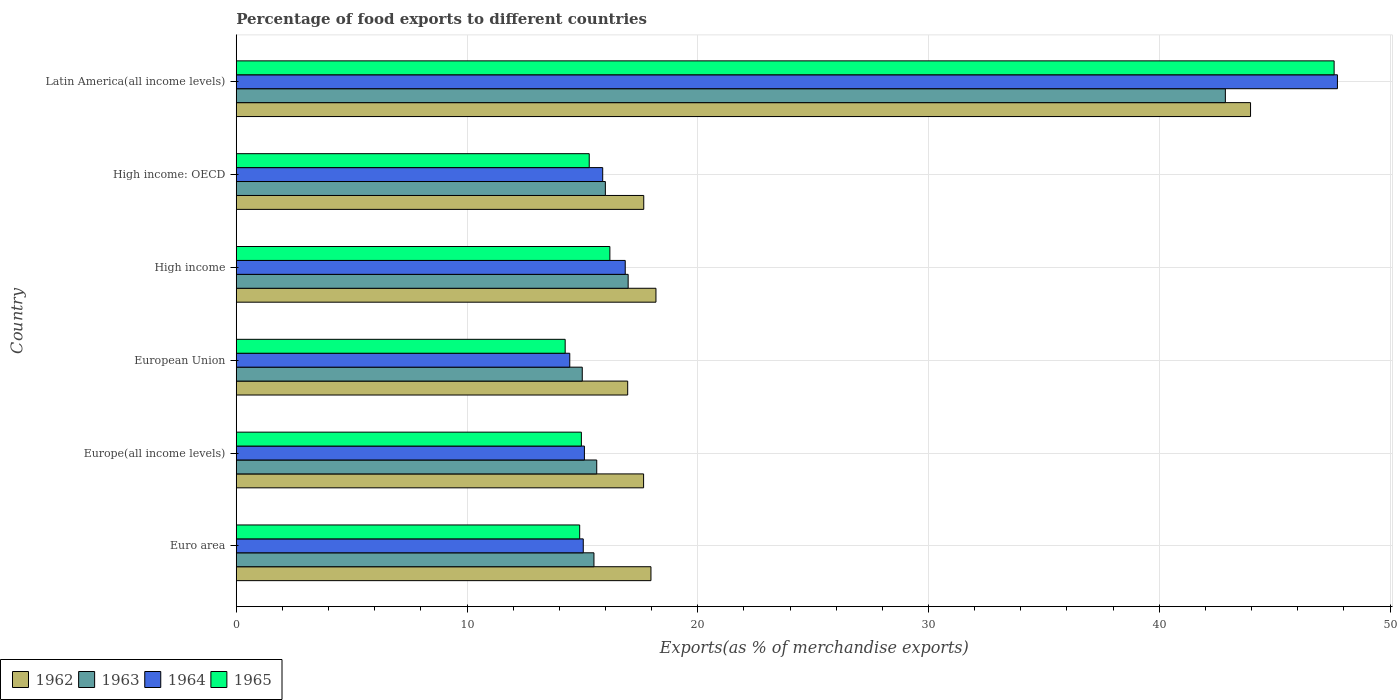How many different coloured bars are there?
Your response must be concise. 4. How many groups of bars are there?
Offer a terse response. 6. Are the number of bars on each tick of the Y-axis equal?
Offer a very short reply. Yes. What is the label of the 5th group of bars from the top?
Make the answer very short. Europe(all income levels). In how many cases, is the number of bars for a given country not equal to the number of legend labels?
Keep it short and to the point. 0. What is the percentage of exports to different countries in 1965 in Euro area?
Offer a very short reply. 14.88. Across all countries, what is the maximum percentage of exports to different countries in 1964?
Your answer should be compact. 47.72. Across all countries, what is the minimum percentage of exports to different countries in 1965?
Ensure brevity in your answer.  14.25. In which country was the percentage of exports to different countries in 1964 maximum?
Give a very brief answer. Latin America(all income levels). In which country was the percentage of exports to different countries in 1963 minimum?
Offer a very short reply. European Union. What is the total percentage of exports to different countries in 1962 in the graph?
Make the answer very short. 132.39. What is the difference between the percentage of exports to different countries in 1962 in Europe(all income levels) and that in High income: OECD?
Keep it short and to the point. -0.01. What is the difference between the percentage of exports to different countries in 1962 in High income and the percentage of exports to different countries in 1965 in European Union?
Offer a very short reply. 3.93. What is the average percentage of exports to different countries in 1963 per country?
Keep it short and to the point. 20.33. What is the difference between the percentage of exports to different countries in 1965 and percentage of exports to different countries in 1962 in Latin America(all income levels)?
Your answer should be compact. 3.62. What is the ratio of the percentage of exports to different countries in 1963 in European Union to that in High income: OECD?
Ensure brevity in your answer.  0.94. Is the percentage of exports to different countries in 1963 in High income less than that in Latin America(all income levels)?
Your answer should be very brief. Yes. Is the difference between the percentage of exports to different countries in 1965 in European Union and Latin America(all income levels) greater than the difference between the percentage of exports to different countries in 1962 in European Union and Latin America(all income levels)?
Keep it short and to the point. No. What is the difference between the highest and the second highest percentage of exports to different countries in 1962?
Offer a very short reply. 25.77. What is the difference between the highest and the lowest percentage of exports to different countries in 1962?
Your answer should be compact. 26.99. In how many countries, is the percentage of exports to different countries in 1962 greater than the average percentage of exports to different countries in 1962 taken over all countries?
Your answer should be compact. 1. Is the sum of the percentage of exports to different countries in 1964 in Euro area and High income: OECD greater than the maximum percentage of exports to different countries in 1963 across all countries?
Keep it short and to the point. No. Is it the case that in every country, the sum of the percentage of exports to different countries in 1964 and percentage of exports to different countries in 1962 is greater than the sum of percentage of exports to different countries in 1965 and percentage of exports to different countries in 1963?
Offer a terse response. No. What does the 4th bar from the bottom in High income represents?
Offer a very short reply. 1965. Is it the case that in every country, the sum of the percentage of exports to different countries in 1963 and percentage of exports to different countries in 1964 is greater than the percentage of exports to different countries in 1962?
Offer a terse response. Yes. How many bars are there?
Ensure brevity in your answer.  24. How many countries are there in the graph?
Your answer should be compact. 6. Does the graph contain any zero values?
Offer a terse response. No. Does the graph contain grids?
Offer a very short reply. Yes. Where does the legend appear in the graph?
Your answer should be very brief. Bottom left. How are the legend labels stacked?
Your response must be concise. Horizontal. What is the title of the graph?
Provide a short and direct response. Percentage of food exports to different countries. Does "1985" appear as one of the legend labels in the graph?
Provide a succinct answer. No. What is the label or title of the X-axis?
Your answer should be very brief. Exports(as % of merchandise exports). What is the label or title of the Y-axis?
Offer a terse response. Country. What is the Exports(as % of merchandise exports) of 1962 in Euro area?
Ensure brevity in your answer.  17.97. What is the Exports(as % of merchandise exports) of 1963 in Euro area?
Your response must be concise. 15.5. What is the Exports(as % of merchandise exports) in 1964 in Euro area?
Provide a succinct answer. 15.04. What is the Exports(as % of merchandise exports) in 1965 in Euro area?
Ensure brevity in your answer.  14.88. What is the Exports(as % of merchandise exports) of 1962 in Europe(all income levels)?
Your response must be concise. 17.65. What is the Exports(as % of merchandise exports) of 1963 in Europe(all income levels)?
Provide a short and direct response. 15.62. What is the Exports(as % of merchandise exports) in 1964 in Europe(all income levels)?
Your answer should be compact. 15.09. What is the Exports(as % of merchandise exports) in 1965 in Europe(all income levels)?
Offer a terse response. 14.96. What is the Exports(as % of merchandise exports) of 1962 in European Union?
Offer a very short reply. 16.96. What is the Exports(as % of merchandise exports) in 1963 in European Union?
Your answer should be very brief. 14.99. What is the Exports(as % of merchandise exports) in 1964 in European Union?
Keep it short and to the point. 14.45. What is the Exports(as % of merchandise exports) of 1965 in European Union?
Your answer should be compact. 14.25. What is the Exports(as % of merchandise exports) of 1962 in High income?
Provide a short and direct response. 18.19. What is the Exports(as % of merchandise exports) in 1963 in High income?
Your response must be concise. 16.98. What is the Exports(as % of merchandise exports) of 1964 in High income?
Provide a short and direct response. 16.86. What is the Exports(as % of merchandise exports) of 1965 in High income?
Your answer should be very brief. 16.19. What is the Exports(as % of merchandise exports) of 1962 in High income: OECD?
Your answer should be compact. 17.66. What is the Exports(as % of merchandise exports) in 1963 in High income: OECD?
Your response must be concise. 16. What is the Exports(as % of merchandise exports) in 1964 in High income: OECD?
Offer a very short reply. 15.88. What is the Exports(as % of merchandise exports) in 1965 in High income: OECD?
Your answer should be very brief. 15.3. What is the Exports(as % of merchandise exports) of 1962 in Latin America(all income levels)?
Provide a short and direct response. 43.96. What is the Exports(as % of merchandise exports) in 1963 in Latin America(all income levels)?
Your answer should be compact. 42.86. What is the Exports(as % of merchandise exports) of 1964 in Latin America(all income levels)?
Provide a succinct answer. 47.72. What is the Exports(as % of merchandise exports) in 1965 in Latin America(all income levels)?
Provide a succinct answer. 47.58. Across all countries, what is the maximum Exports(as % of merchandise exports) of 1962?
Provide a succinct answer. 43.96. Across all countries, what is the maximum Exports(as % of merchandise exports) in 1963?
Make the answer very short. 42.86. Across all countries, what is the maximum Exports(as % of merchandise exports) of 1964?
Your response must be concise. 47.72. Across all countries, what is the maximum Exports(as % of merchandise exports) of 1965?
Keep it short and to the point. 47.58. Across all countries, what is the minimum Exports(as % of merchandise exports) of 1962?
Provide a succinct answer. 16.96. Across all countries, what is the minimum Exports(as % of merchandise exports) of 1963?
Make the answer very short. 14.99. Across all countries, what is the minimum Exports(as % of merchandise exports) in 1964?
Offer a very short reply. 14.45. Across all countries, what is the minimum Exports(as % of merchandise exports) of 1965?
Offer a terse response. 14.25. What is the total Exports(as % of merchandise exports) in 1962 in the graph?
Your response must be concise. 132.39. What is the total Exports(as % of merchandise exports) in 1963 in the graph?
Ensure brevity in your answer.  121.96. What is the total Exports(as % of merchandise exports) in 1964 in the graph?
Your answer should be very brief. 125.04. What is the total Exports(as % of merchandise exports) of 1965 in the graph?
Offer a terse response. 123.16. What is the difference between the Exports(as % of merchandise exports) in 1962 in Euro area and that in Europe(all income levels)?
Offer a terse response. 0.32. What is the difference between the Exports(as % of merchandise exports) in 1963 in Euro area and that in Europe(all income levels)?
Ensure brevity in your answer.  -0.12. What is the difference between the Exports(as % of merchandise exports) of 1964 in Euro area and that in Europe(all income levels)?
Provide a succinct answer. -0.05. What is the difference between the Exports(as % of merchandise exports) of 1965 in Euro area and that in Europe(all income levels)?
Provide a short and direct response. -0.07. What is the difference between the Exports(as % of merchandise exports) of 1962 in Euro area and that in European Union?
Offer a terse response. 1.01. What is the difference between the Exports(as % of merchandise exports) in 1963 in Euro area and that in European Union?
Your answer should be very brief. 0.51. What is the difference between the Exports(as % of merchandise exports) in 1964 in Euro area and that in European Union?
Keep it short and to the point. 0.58. What is the difference between the Exports(as % of merchandise exports) of 1965 in Euro area and that in European Union?
Give a very brief answer. 0.63. What is the difference between the Exports(as % of merchandise exports) in 1962 in Euro area and that in High income?
Make the answer very short. -0.22. What is the difference between the Exports(as % of merchandise exports) of 1963 in Euro area and that in High income?
Keep it short and to the point. -1.48. What is the difference between the Exports(as % of merchandise exports) in 1964 in Euro area and that in High income?
Your response must be concise. -1.82. What is the difference between the Exports(as % of merchandise exports) in 1965 in Euro area and that in High income?
Offer a very short reply. -1.31. What is the difference between the Exports(as % of merchandise exports) of 1962 in Euro area and that in High income: OECD?
Offer a very short reply. 0.31. What is the difference between the Exports(as % of merchandise exports) in 1963 in Euro area and that in High income: OECD?
Provide a succinct answer. -0.49. What is the difference between the Exports(as % of merchandise exports) of 1964 in Euro area and that in High income: OECD?
Make the answer very short. -0.84. What is the difference between the Exports(as % of merchandise exports) in 1965 in Euro area and that in High income: OECD?
Your response must be concise. -0.41. What is the difference between the Exports(as % of merchandise exports) in 1962 in Euro area and that in Latin America(all income levels)?
Ensure brevity in your answer.  -25.98. What is the difference between the Exports(as % of merchandise exports) in 1963 in Euro area and that in Latin America(all income levels)?
Provide a succinct answer. -27.36. What is the difference between the Exports(as % of merchandise exports) in 1964 in Euro area and that in Latin America(all income levels)?
Ensure brevity in your answer.  -32.68. What is the difference between the Exports(as % of merchandise exports) of 1965 in Euro area and that in Latin America(all income levels)?
Offer a terse response. -32.69. What is the difference between the Exports(as % of merchandise exports) of 1962 in Europe(all income levels) and that in European Union?
Provide a short and direct response. 0.69. What is the difference between the Exports(as % of merchandise exports) of 1963 in Europe(all income levels) and that in European Union?
Provide a succinct answer. 0.63. What is the difference between the Exports(as % of merchandise exports) in 1964 in Europe(all income levels) and that in European Union?
Your answer should be very brief. 0.63. What is the difference between the Exports(as % of merchandise exports) of 1965 in Europe(all income levels) and that in European Union?
Give a very brief answer. 0.7. What is the difference between the Exports(as % of merchandise exports) in 1962 in Europe(all income levels) and that in High income?
Keep it short and to the point. -0.54. What is the difference between the Exports(as % of merchandise exports) in 1963 in Europe(all income levels) and that in High income?
Your answer should be very brief. -1.36. What is the difference between the Exports(as % of merchandise exports) in 1964 in Europe(all income levels) and that in High income?
Your response must be concise. -1.77. What is the difference between the Exports(as % of merchandise exports) of 1965 in Europe(all income levels) and that in High income?
Your answer should be compact. -1.23. What is the difference between the Exports(as % of merchandise exports) of 1962 in Europe(all income levels) and that in High income: OECD?
Give a very brief answer. -0.01. What is the difference between the Exports(as % of merchandise exports) of 1963 in Europe(all income levels) and that in High income: OECD?
Your response must be concise. -0.37. What is the difference between the Exports(as % of merchandise exports) in 1964 in Europe(all income levels) and that in High income: OECD?
Your response must be concise. -0.79. What is the difference between the Exports(as % of merchandise exports) in 1965 in Europe(all income levels) and that in High income: OECD?
Provide a short and direct response. -0.34. What is the difference between the Exports(as % of merchandise exports) in 1962 in Europe(all income levels) and that in Latin America(all income levels)?
Your answer should be very brief. -26.3. What is the difference between the Exports(as % of merchandise exports) in 1963 in Europe(all income levels) and that in Latin America(all income levels)?
Keep it short and to the point. -27.24. What is the difference between the Exports(as % of merchandise exports) in 1964 in Europe(all income levels) and that in Latin America(all income levels)?
Offer a very short reply. -32.63. What is the difference between the Exports(as % of merchandise exports) in 1965 in Europe(all income levels) and that in Latin America(all income levels)?
Offer a terse response. -32.62. What is the difference between the Exports(as % of merchandise exports) in 1962 in European Union and that in High income?
Provide a succinct answer. -1.22. What is the difference between the Exports(as % of merchandise exports) in 1963 in European Union and that in High income?
Offer a terse response. -1.99. What is the difference between the Exports(as % of merchandise exports) in 1964 in European Union and that in High income?
Keep it short and to the point. -2.4. What is the difference between the Exports(as % of merchandise exports) of 1965 in European Union and that in High income?
Give a very brief answer. -1.94. What is the difference between the Exports(as % of merchandise exports) in 1962 in European Union and that in High income: OECD?
Your answer should be very brief. -0.7. What is the difference between the Exports(as % of merchandise exports) of 1963 in European Union and that in High income: OECD?
Ensure brevity in your answer.  -1. What is the difference between the Exports(as % of merchandise exports) of 1964 in European Union and that in High income: OECD?
Ensure brevity in your answer.  -1.43. What is the difference between the Exports(as % of merchandise exports) of 1965 in European Union and that in High income: OECD?
Your answer should be very brief. -1.04. What is the difference between the Exports(as % of merchandise exports) of 1962 in European Union and that in Latin America(all income levels)?
Your answer should be very brief. -26.99. What is the difference between the Exports(as % of merchandise exports) in 1963 in European Union and that in Latin America(all income levels)?
Your answer should be compact. -27.87. What is the difference between the Exports(as % of merchandise exports) in 1964 in European Union and that in Latin America(all income levels)?
Ensure brevity in your answer.  -33.27. What is the difference between the Exports(as % of merchandise exports) of 1965 in European Union and that in Latin America(all income levels)?
Offer a terse response. -33.32. What is the difference between the Exports(as % of merchandise exports) in 1962 in High income and that in High income: OECD?
Make the answer very short. 0.53. What is the difference between the Exports(as % of merchandise exports) in 1963 in High income and that in High income: OECD?
Provide a short and direct response. 0.99. What is the difference between the Exports(as % of merchandise exports) in 1964 in High income and that in High income: OECD?
Make the answer very short. 0.98. What is the difference between the Exports(as % of merchandise exports) in 1965 in High income and that in High income: OECD?
Ensure brevity in your answer.  0.89. What is the difference between the Exports(as % of merchandise exports) in 1962 in High income and that in Latin America(all income levels)?
Provide a succinct answer. -25.77. What is the difference between the Exports(as % of merchandise exports) of 1963 in High income and that in Latin America(all income levels)?
Keep it short and to the point. -25.88. What is the difference between the Exports(as % of merchandise exports) of 1964 in High income and that in Latin America(all income levels)?
Provide a succinct answer. -30.86. What is the difference between the Exports(as % of merchandise exports) of 1965 in High income and that in Latin America(all income levels)?
Your response must be concise. -31.39. What is the difference between the Exports(as % of merchandise exports) of 1962 in High income: OECD and that in Latin America(all income levels)?
Make the answer very short. -26.3. What is the difference between the Exports(as % of merchandise exports) in 1963 in High income: OECD and that in Latin America(all income levels)?
Ensure brevity in your answer.  -26.87. What is the difference between the Exports(as % of merchandise exports) in 1964 in High income: OECD and that in Latin America(all income levels)?
Make the answer very short. -31.84. What is the difference between the Exports(as % of merchandise exports) of 1965 in High income: OECD and that in Latin America(all income levels)?
Ensure brevity in your answer.  -32.28. What is the difference between the Exports(as % of merchandise exports) of 1962 in Euro area and the Exports(as % of merchandise exports) of 1963 in Europe(all income levels)?
Offer a terse response. 2.35. What is the difference between the Exports(as % of merchandise exports) of 1962 in Euro area and the Exports(as % of merchandise exports) of 1964 in Europe(all income levels)?
Your answer should be very brief. 2.88. What is the difference between the Exports(as % of merchandise exports) of 1962 in Euro area and the Exports(as % of merchandise exports) of 1965 in Europe(all income levels)?
Give a very brief answer. 3.02. What is the difference between the Exports(as % of merchandise exports) of 1963 in Euro area and the Exports(as % of merchandise exports) of 1964 in Europe(all income levels)?
Ensure brevity in your answer.  0.41. What is the difference between the Exports(as % of merchandise exports) in 1963 in Euro area and the Exports(as % of merchandise exports) in 1965 in Europe(all income levels)?
Your answer should be compact. 0.55. What is the difference between the Exports(as % of merchandise exports) of 1964 in Euro area and the Exports(as % of merchandise exports) of 1965 in Europe(all income levels)?
Your answer should be very brief. 0.08. What is the difference between the Exports(as % of merchandise exports) in 1962 in Euro area and the Exports(as % of merchandise exports) in 1963 in European Union?
Give a very brief answer. 2.98. What is the difference between the Exports(as % of merchandise exports) in 1962 in Euro area and the Exports(as % of merchandise exports) in 1964 in European Union?
Make the answer very short. 3.52. What is the difference between the Exports(as % of merchandise exports) of 1962 in Euro area and the Exports(as % of merchandise exports) of 1965 in European Union?
Give a very brief answer. 3.72. What is the difference between the Exports(as % of merchandise exports) of 1963 in Euro area and the Exports(as % of merchandise exports) of 1964 in European Union?
Give a very brief answer. 1.05. What is the difference between the Exports(as % of merchandise exports) in 1963 in Euro area and the Exports(as % of merchandise exports) in 1965 in European Union?
Offer a very short reply. 1.25. What is the difference between the Exports(as % of merchandise exports) of 1964 in Euro area and the Exports(as % of merchandise exports) of 1965 in European Union?
Keep it short and to the point. 0.78. What is the difference between the Exports(as % of merchandise exports) in 1962 in Euro area and the Exports(as % of merchandise exports) in 1963 in High income?
Offer a very short reply. 0.99. What is the difference between the Exports(as % of merchandise exports) in 1962 in Euro area and the Exports(as % of merchandise exports) in 1964 in High income?
Make the answer very short. 1.11. What is the difference between the Exports(as % of merchandise exports) in 1962 in Euro area and the Exports(as % of merchandise exports) in 1965 in High income?
Your answer should be very brief. 1.78. What is the difference between the Exports(as % of merchandise exports) of 1963 in Euro area and the Exports(as % of merchandise exports) of 1964 in High income?
Keep it short and to the point. -1.36. What is the difference between the Exports(as % of merchandise exports) in 1963 in Euro area and the Exports(as % of merchandise exports) in 1965 in High income?
Give a very brief answer. -0.69. What is the difference between the Exports(as % of merchandise exports) in 1964 in Euro area and the Exports(as % of merchandise exports) in 1965 in High income?
Make the answer very short. -1.15. What is the difference between the Exports(as % of merchandise exports) of 1962 in Euro area and the Exports(as % of merchandise exports) of 1963 in High income: OECD?
Provide a short and direct response. 1.98. What is the difference between the Exports(as % of merchandise exports) in 1962 in Euro area and the Exports(as % of merchandise exports) in 1964 in High income: OECD?
Your answer should be very brief. 2.09. What is the difference between the Exports(as % of merchandise exports) of 1962 in Euro area and the Exports(as % of merchandise exports) of 1965 in High income: OECD?
Give a very brief answer. 2.67. What is the difference between the Exports(as % of merchandise exports) of 1963 in Euro area and the Exports(as % of merchandise exports) of 1964 in High income: OECD?
Give a very brief answer. -0.38. What is the difference between the Exports(as % of merchandise exports) in 1963 in Euro area and the Exports(as % of merchandise exports) in 1965 in High income: OECD?
Give a very brief answer. 0.2. What is the difference between the Exports(as % of merchandise exports) in 1964 in Euro area and the Exports(as % of merchandise exports) in 1965 in High income: OECD?
Provide a succinct answer. -0.26. What is the difference between the Exports(as % of merchandise exports) in 1962 in Euro area and the Exports(as % of merchandise exports) in 1963 in Latin America(all income levels)?
Your answer should be compact. -24.89. What is the difference between the Exports(as % of merchandise exports) in 1962 in Euro area and the Exports(as % of merchandise exports) in 1964 in Latin America(all income levels)?
Make the answer very short. -29.75. What is the difference between the Exports(as % of merchandise exports) of 1962 in Euro area and the Exports(as % of merchandise exports) of 1965 in Latin America(all income levels)?
Offer a terse response. -29.61. What is the difference between the Exports(as % of merchandise exports) of 1963 in Euro area and the Exports(as % of merchandise exports) of 1964 in Latin America(all income levels)?
Offer a terse response. -32.22. What is the difference between the Exports(as % of merchandise exports) of 1963 in Euro area and the Exports(as % of merchandise exports) of 1965 in Latin America(all income levels)?
Your response must be concise. -32.08. What is the difference between the Exports(as % of merchandise exports) of 1964 in Euro area and the Exports(as % of merchandise exports) of 1965 in Latin America(all income levels)?
Ensure brevity in your answer.  -32.54. What is the difference between the Exports(as % of merchandise exports) of 1962 in Europe(all income levels) and the Exports(as % of merchandise exports) of 1963 in European Union?
Your answer should be compact. 2.66. What is the difference between the Exports(as % of merchandise exports) in 1962 in Europe(all income levels) and the Exports(as % of merchandise exports) in 1964 in European Union?
Your response must be concise. 3.2. What is the difference between the Exports(as % of merchandise exports) of 1962 in Europe(all income levels) and the Exports(as % of merchandise exports) of 1965 in European Union?
Offer a terse response. 3.4. What is the difference between the Exports(as % of merchandise exports) of 1963 in Europe(all income levels) and the Exports(as % of merchandise exports) of 1964 in European Union?
Make the answer very short. 1.17. What is the difference between the Exports(as % of merchandise exports) of 1963 in Europe(all income levels) and the Exports(as % of merchandise exports) of 1965 in European Union?
Provide a short and direct response. 1.37. What is the difference between the Exports(as % of merchandise exports) in 1964 in Europe(all income levels) and the Exports(as % of merchandise exports) in 1965 in European Union?
Keep it short and to the point. 0.83. What is the difference between the Exports(as % of merchandise exports) of 1962 in Europe(all income levels) and the Exports(as % of merchandise exports) of 1963 in High income?
Your response must be concise. 0.67. What is the difference between the Exports(as % of merchandise exports) of 1962 in Europe(all income levels) and the Exports(as % of merchandise exports) of 1964 in High income?
Make the answer very short. 0.8. What is the difference between the Exports(as % of merchandise exports) of 1962 in Europe(all income levels) and the Exports(as % of merchandise exports) of 1965 in High income?
Ensure brevity in your answer.  1.46. What is the difference between the Exports(as % of merchandise exports) in 1963 in Europe(all income levels) and the Exports(as % of merchandise exports) in 1964 in High income?
Offer a terse response. -1.24. What is the difference between the Exports(as % of merchandise exports) of 1963 in Europe(all income levels) and the Exports(as % of merchandise exports) of 1965 in High income?
Provide a short and direct response. -0.57. What is the difference between the Exports(as % of merchandise exports) in 1964 in Europe(all income levels) and the Exports(as % of merchandise exports) in 1965 in High income?
Offer a terse response. -1.1. What is the difference between the Exports(as % of merchandise exports) in 1962 in Europe(all income levels) and the Exports(as % of merchandise exports) in 1963 in High income: OECD?
Your response must be concise. 1.66. What is the difference between the Exports(as % of merchandise exports) of 1962 in Europe(all income levels) and the Exports(as % of merchandise exports) of 1964 in High income: OECD?
Offer a terse response. 1.77. What is the difference between the Exports(as % of merchandise exports) in 1962 in Europe(all income levels) and the Exports(as % of merchandise exports) in 1965 in High income: OECD?
Offer a terse response. 2.36. What is the difference between the Exports(as % of merchandise exports) in 1963 in Europe(all income levels) and the Exports(as % of merchandise exports) in 1964 in High income: OECD?
Offer a very short reply. -0.26. What is the difference between the Exports(as % of merchandise exports) of 1963 in Europe(all income levels) and the Exports(as % of merchandise exports) of 1965 in High income: OECD?
Your answer should be compact. 0.33. What is the difference between the Exports(as % of merchandise exports) of 1964 in Europe(all income levels) and the Exports(as % of merchandise exports) of 1965 in High income: OECD?
Offer a terse response. -0.21. What is the difference between the Exports(as % of merchandise exports) of 1962 in Europe(all income levels) and the Exports(as % of merchandise exports) of 1963 in Latin America(all income levels)?
Ensure brevity in your answer.  -25.21. What is the difference between the Exports(as % of merchandise exports) of 1962 in Europe(all income levels) and the Exports(as % of merchandise exports) of 1964 in Latin America(all income levels)?
Offer a very short reply. -30.07. What is the difference between the Exports(as % of merchandise exports) of 1962 in Europe(all income levels) and the Exports(as % of merchandise exports) of 1965 in Latin America(all income levels)?
Provide a succinct answer. -29.92. What is the difference between the Exports(as % of merchandise exports) of 1963 in Europe(all income levels) and the Exports(as % of merchandise exports) of 1964 in Latin America(all income levels)?
Provide a short and direct response. -32.1. What is the difference between the Exports(as % of merchandise exports) of 1963 in Europe(all income levels) and the Exports(as % of merchandise exports) of 1965 in Latin America(all income levels)?
Your answer should be very brief. -31.96. What is the difference between the Exports(as % of merchandise exports) of 1964 in Europe(all income levels) and the Exports(as % of merchandise exports) of 1965 in Latin America(all income levels)?
Your answer should be very brief. -32.49. What is the difference between the Exports(as % of merchandise exports) in 1962 in European Union and the Exports(as % of merchandise exports) in 1963 in High income?
Offer a very short reply. -0.02. What is the difference between the Exports(as % of merchandise exports) of 1962 in European Union and the Exports(as % of merchandise exports) of 1964 in High income?
Ensure brevity in your answer.  0.11. What is the difference between the Exports(as % of merchandise exports) in 1962 in European Union and the Exports(as % of merchandise exports) in 1965 in High income?
Ensure brevity in your answer.  0.77. What is the difference between the Exports(as % of merchandise exports) in 1963 in European Union and the Exports(as % of merchandise exports) in 1964 in High income?
Provide a succinct answer. -1.86. What is the difference between the Exports(as % of merchandise exports) of 1963 in European Union and the Exports(as % of merchandise exports) of 1965 in High income?
Give a very brief answer. -1.2. What is the difference between the Exports(as % of merchandise exports) of 1964 in European Union and the Exports(as % of merchandise exports) of 1965 in High income?
Offer a very short reply. -1.74. What is the difference between the Exports(as % of merchandise exports) of 1962 in European Union and the Exports(as % of merchandise exports) of 1963 in High income: OECD?
Your response must be concise. 0.97. What is the difference between the Exports(as % of merchandise exports) of 1962 in European Union and the Exports(as % of merchandise exports) of 1964 in High income: OECD?
Your answer should be compact. 1.08. What is the difference between the Exports(as % of merchandise exports) of 1962 in European Union and the Exports(as % of merchandise exports) of 1965 in High income: OECD?
Offer a very short reply. 1.67. What is the difference between the Exports(as % of merchandise exports) of 1963 in European Union and the Exports(as % of merchandise exports) of 1964 in High income: OECD?
Provide a short and direct response. -0.89. What is the difference between the Exports(as % of merchandise exports) in 1963 in European Union and the Exports(as % of merchandise exports) in 1965 in High income: OECD?
Your answer should be very brief. -0.3. What is the difference between the Exports(as % of merchandise exports) in 1964 in European Union and the Exports(as % of merchandise exports) in 1965 in High income: OECD?
Give a very brief answer. -0.84. What is the difference between the Exports(as % of merchandise exports) in 1962 in European Union and the Exports(as % of merchandise exports) in 1963 in Latin America(all income levels)?
Keep it short and to the point. -25.9. What is the difference between the Exports(as % of merchandise exports) of 1962 in European Union and the Exports(as % of merchandise exports) of 1964 in Latin America(all income levels)?
Your response must be concise. -30.76. What is the difference between the Exports(as % of merchandise exports) of 1962 in European Union and the Exports(as % of merchandise exports) of 1965 in Latin America(all income levels)?
Keep it short and to the point. -30.61. What is the difference between the Exports(as % of merchandise exports) of 1963 in European Union and the Exports(as % of merchandise exports) of 1964 in Latin America(all income levels)?
Ensure brevity in your answer.  -32.73. What is the difference between the Exports(as % of merchandise exports) in 1963 in European Union and the Exports(as % of merchandise exports) in 1965 in Latin America(all income levels)?
Provide a short and direct response. -32.58. What is the difference between the Exports(as % of merchandise exports) in 1964 in European Union and the Exports(as % of merchandise exports) in 1965 in Latin America(all income levels)?
Provide a succinct answer. -33.12. What is the difference between the Exports(as % of merchandise exports) of 1962 in High income and the Exports(as % of merchandise exports) of 1963 in High income: OECD?
Make the answer very short. 2.19. What is the difference between the Exports(as % of merchandise exports) of 1962 in High income and the Exports(as % of merchandise exports) of 1964 in High income: OECD?
Your response must be concise. 2.31. What is the difference between the Exports(as % of merchandise exports) of 1962 in High income and the Exports(as % of merchandise exports) of 1965 in High income: OECD?
Keep it short and to the point. 2.89. What is the difference between the Exports(as % of merchandise exports) of 1963 in High income and the Exports(as % of merchandise exports) of 1964 in High income: OECD?
Give a very brief answer. 1.1. What is the difference between the Exports(as % of merchandise exports) of 1963 in High income and the Exports(as % of merchandise exports) of 1965 in High income: OECD?
Your answer should be very brief. 1.69. What is the difference between the Exports(as % of merchandise exports) in 1964 in High income and the Exports(as % of merchandise exports) in 1965 in High income: OECD?
Give a very brief answer. 1.56. What is the difference between the Exports(as % of merchandise exports) of 1962 in High income and the Exports(as % of merchandise exports) of 1963 in Latin America(all income levels)?
Offer a terse response. -24.68. What is the difference between the Exports(as % of merchandise exports) of 1962 in High income and the Exports(as % of merchandise exports) of 1964 in Latin America(all income levels)?
Offer a terse response. -29.53. What is the difference between the Exports(as % of merchandise exports) in 1962 in High income and the Exports(as % of merchandise exports) in 1965 in Latin America(all income levels)?
Make the answer very short. -29.39. What is the difference between the Exports(as % of merchandise exports) of 1963 in High income and the Exports(as % of merchandise exports) of 1964 in Latin America(all income levels)?
Ensure brevity in your answer.  -30.74. What is the difference between the Exports(as % of merchandise exports) in 1963 in High income and the Exports(as % of merchandise exports) in 1965 in Latin America(all income levels)?
Ensure brevity in your answer.  -30.59. What is the difference between the Exports(as % of merchandise exports) in 1964 in High income and the Exports(as % of merchandise exports) in 1965 in Latin America(all income levels)?
Keep it short and to the point. -30.72. What is the difference between the Exports(as % of merchandise exports) of 1962 in High income: OECD and the Exports(as % of merchandise exports) of 1963 in Latin America(all income levels)?
Give a very brief answer. -25.2. What is the difference between the Exports(as % of merchandise exports) of 1962 in High income: OECD and the Exports(as % of merchandise exports) of 1964 in Latin America(all income levels)?
Ensure brevity in your answer.  -30.06. What is the difference between the Exports(as % of merchandise exports) of 1962 in High income: OECD and the Exports(as % of merchandise exports) of 1965 in Latin America(all income levels)?
Keep it short and to the point. -29.92. What is the difference between the Exports(as % of merchandise exports) of 1963 in High income: OECD and the Exports(as % of merchandise exports) of 1964 in Latin America(all income levels)?
Keep it short and to the point. -31.73. What is the difference between the Exports(as % of merchandise exports) in 1963 in High income: OECD and the Exports(as % of merchandise exports) in 1965 in Latin America(all income levels)?
Offer a terse response. -31.58. What is the difference between the Exports(as % of merchandise exports) of 1964 in High income: OECD and the Exports(as % of merchandise exports) of 1965 in Latin America(all income levels)?
Keep it short and to the point. -31.7. What is the average Exports(as % of merchandise exports) in 1962 per country?
Your response must be concise. 22.07. What is the average Exports(as % of merchandise exports) of 1963 per country?
Offer a very short reply. 20.33. What is the average Exports(as % of merchandise exports) in 1964 per country?
Ensure brevity in your answer.  20.84. What is the average Exports(as % of merchandise exports) in 1965 per country?
Keep it short and to the point. 20.53. What is the difference between the Exports(as % of merchandise exports) in 1962 and Exports(as % of merchandise exports) in 1963 in Euro area?
Your answer should be very brief. 2.47. What is the difference between the Exports(as % of merchandise exports) of 1962 and Exports(as % of merchandise exports) of 1964 in Euro area?
Provide a short and direct response. 2.93. What is the difference between the Exports(as % of merchandise exports) in 1962 and Exports(as % of merchandise exports) in 1965 in Euro area?
Provide a short and direct response. 3.09. What is the difference between the Exports(as % of merchandise exports) of 1963 and Exports(as % of merchandise exports) of 1964 in Euro area?
Make the answer very short. 0.46. What is the difference between the Exports(as % of merchandise exports) in 1963 and Exports(as % of merchandise exports) in 1965 in Euro area?
Keep it short and to the point. 0.62. What is the difference between the Exports(as % of merchandise exports) of 1964 and Exports(as % of merchandise exports) of 1965 in Euro area?
Provide a short and direct response. 0.15. What is the difference between the Exports(as % of merchandise exports) in 1962 and Exports(as % of merchandise exports) in 1963 in Europe(all income levels)?
Offer a very short reply. 2.03. What is the difference between the Exports(as % of merchandise exports) of 1962 and Exports(as % of merchandise exports) of 1964 in Europe(all income levels)?
Your response must be concise. 2.57. What is the difference between the Exports(as % of merchandise exports) of 1962 and Exports(as % of merchandise exports) of 1965 in Europe(all income levels)?
Offer a very short reply. 2.7. What is the difference between the Exports(as % of merchandise exports) in 1963 and Exports(as % of merchandise exports) in 1964 in Europe(all income levels)?
Give a very brief answer. 0.53. What is the difference between the Exports(as % of merchandise exports) in 1963 and Exports(as % of merchandise exports) in 1965 in Europe(all income levels)?
Provide a succinct answer. 0.67. What is the difference between the Exports(as % of merchandise exports) of 1964 and Exports(as % of merchandise exports) of 1965 in Europe(all income levels)?
Your answer should be compact. 0.13. What is the difference between the Exports(as % of merchandise exports) in 1962 and Exports(as % of merchandise exports) in 1963 in European Union?
Ensure brevity in your answer.  1.97. What is the difference between the Exports(as % of merchandise exports) of 1962 and Exports(as % of merchandise exports) of 1964 in European Union?
Make the answer very short. 2.51. What is the difference between the Exports(as % of merchandise exports) of 1962 and Exports(as % of merchandise exports) of 1965 in European Union?
Your answer should be very brief. 2.71. What is the difference between the Exports(as % of merchandise exports) in 1963 and Exports(as % of merchandise exports) in 1964 in European Union?
Keep it short and to the point. 0.54. What is the difference between the Exports(as % of merchandise exports) of 1963 and Exports(as % of merchandise exports) of 1965 in European Union?
Make the answer very short. 0.74. What is the difference between the Exports(as % of merchandise exports) in 1964 and Exports(as % of merchandise exports) in 1965 in European Union?
Provide a short and direct response. 0.2. What is the difference between the Exports(as % of merchandise exports) of 1962 and Exports(as % of merchandise exports) of 1963 in High income?
Ensure brevity in your answer.  1.2. What is the difference between the Exports(as % of merchandise exports) of 1962 and Exports(as % of merchandise exports) of 1964 in High income?
Make the answer very short. 1.33. What is the difference between the Exports(as % of merchandise exports) of 1962 and Exports(as % of merchandise exports) of 1965 in High income?
Provide a succinct answer. 2. What is the difference between the Exports(as % of merchandise exports) in 1963 and Exports(as % of merchandise exports) in 1964 in High income?
Ensure brevity in your answer.  0.13. What is the difference between the Exports(as % of merchandise exports) in 1963 and Exports(as % of merchandise exports) in 1965 in High income?
Your answer should be very brief. 0.79. What is the difference between the Exports(as % of merchandise exports) of 1964 and Exports(as % of merchandise exports) of 1965 in High income?
Offer a very short reply. 0.67. What is the difference between the Exports(as % of merchandise exports) of 1962 and Exports(as % of merchandise exports) of 1963 in High income: OECD?
Keep it short and to the point. 1.66. What is the difference between the Exports(as % of merchandise exports) in 1962 and Exports(as % of merchandise exports) in 1964 in High income: OECD?
Make the answer very short. 1.78. What is the difference between the Exports(as % of merchandise exports) of 1962 and Exports(as % of merchandise exports) of 1965 in High income: OECD?
Your answer should be very brief. 2.36. What is the difference between the Exports(as % of merchandise exports) in 1963 and Exports(as % of merchandise exports) in 1964 in High income: OECD?
Provide a short and direct response. 0.12. What is the difference between the Exports(as % of merchandise exports) in 1963 and Exports(as % of merchandise exports) in 1965 in High income: OECD?
Provide a short and direct response. 0.7. What is the difference between the Exports(as % of merchandise exports) in 1964 and Exports(as % of merchandise exports) in 1965 in High income: OECD?
Your answer should be compact. 0.58. What is the difference between the Exports(as % of merchandise exports) of 1962 and Exports(as % of merchandise exports) of 1963 in Latin America(all income levels)?
Your response must be concise. 1.09. What is the difference between the Exports(as % of merchandise exports) of 1962 and Exports(as % of merchandise exports) of 1964 in Latin America(all income levels)?
Keep it short and to the point. -3.77. What is the difference between the Exports(as % of merchandise exports) in 1962 and Exports(as % of merchandise exports) in 1965 in Latin America(all income levels)?
Offer a terse response. -3.62. What is the difference between the Exports(as % of merchandise exports) in 1963 and Exports(as % of merchandise exports) in 1964 in Latin America(all income levels)?
Keep it short and to the point. -4.86. What is the difference between the Exports(as % of merchandise exports) in 1963 and Exports(as % of merchandise exports) in 1965 in Latin America(all income levels)?
Ensure brevity in your answer.  -4.71. What is the difference between the Exports(as % of merchandise exports) in 1964 and Exports(as % of merchandise exports) in 1965 in Latin America(all income levels)?
Ensure brevity in your answer.  0.14. What is the ratio of the Exports(as % of merchandise exports) in 1962 in Euro area to that in Europe(all income levels)?
Your answer should be compact. 1.02. What is the ratio of the Exports(as % of merchandise exports) of 1965 in Euro area to that in Europe(all income levels)?
Provide a succinct answer. 1. What is the ratio of the Exports(as % of merchandise exports) in 1962 in Euro area to that in European Union?
Your answer should be very brief. 1.06. What is the ratio of the Exports(as % of merchandise exports) of 1963 in Euro area to that in European Union?
Ensure brevity in your answer.  1.03. What is the ratio of the Exports(as % of merchandise exports) in 1964 in Euro area to that in European Union?
Give a very brief answer. 1.04. What is the ratio of the Exports(as % of merchandise exports) in 1965 in Euro area to that in European Union?
Your answer should be compact. 1.04. What is the ratio of the Exports(as % of merchandise exports) in 1962 in Euro area to that in High income?
Offer a very short reply. 0.99. What is the ratio of the Exports(as % of merchandise exports) in 1963 in Euro area to that in High income?
Offer a very short reply. 0.91. What is the ratio of the Exports(as % of merchandise exports) in 1964 in Euro area to that in High income?
Ensure brevity in your answer.  0.89. What is the ratio of the Exports(as % of merchandise exports) in 1965 in Euro area to that in High income?
Give a very brief answer. 0.92. What is the ratio of the Exports(as % of merchandise exports) of 1962 in Euro area to that in High income: OECD?
Provide a short and direct response. 1.02. What is the ratio of the Exports(as % of merchandise exports) in 1963 in Euro area to that in High income: OECD?
Your answer should be very brief. 0.97. What is the ratio of the Exports(as % of merchandise exports) of 1964 in Euro area to that in High income: OECD?
Your response must be concise. 0.95. What is the ratio of the Exports(as % of merchandise exports) of 1965 in Euro area to that in High income: OECD?
Make the answer very short. 0.97. What is the ratio of the Exports(as % of merchandise exports) of 1962 in Euro area to that in Latin America(all income levels)?
Your answer should be very brief. 0.41. What is the ratio of the Exports(as % of merchandise exports) of 1963 in Euro area to that in Latin America(all income levels)?
Provide a short and direct response. 0.36. What is the ratio of the Exports(as % of merchandise exports) in 1964 in Euro area to that in Latin America(all income levels)?
Keep it short and to the point. 0.32. What is the ratio of the Exports(as % of merchandise exports) of 1965 in Euro area to that in Latin America(all income levels)?
Give a very brief answer. 0.31. What is the ratio of the Exports(as % of merchandise exports) in 1962 in Europe(all income levels) to that in European Union?
Offer a terse response. 1.04. What is the ratio of the Exports(as % of merchandise exports) of 1963 in Europe(all income levels) to that in European Union?
Give a very brief answer. 1.04. What is the ratio of the Exports(as % of merchandise exports) of 1964 in Europe(all income levels) to that in European Union?
Your answer should be very brief. 1.04. What is the ratio of the Exports(as % of merchandise exports) in 1965 in Europe(all income levels) to that in European Union?
Provide a short and direct response. 1.05. What is the ratio of the Exports(as % of merchandise exports) in 1962 in Europe(all income levels) to that in High income?
Keep it short and to the point. 0.97. What is the ratio of the Exports(as % of merchandise exports) of 1963 in Europe(all income levels) to that in High income?
Your answer should be compact. 0.92. What is the ratio of the Exports(as % of merchandise exports) of 1964 in Europe(all income levels) to that in High income?
Offer a very short reply. 0.9. What is the ratio of the Exports(as % of merchandise exports) of 1965 in Europe(all income levels) to that in High income?
Ensure brevity in your answer.  0.92. What is the ratio of the Exports(as % of merchandise exports) of 1963 in Europe(all income levels) to that in High income: OECD?
Keep it short and to the point. 0.98. What is the ratio of the Exports(as % of merchandise exports) of 1964 in Europe(all income levels) to that in High income: OECD?
Offer a terse response. 0.95. What is the ratio of the Exports(as % of merchandise exports) in 1965 in Europe(all income levels) to that in High income: OECD?
Your response must be concise. 0.98. What is the ratio of the Exports(as % of merchandise exports) in 1962 in Europe(all income levels) to that in Latin America(all income levels)?
Keep it short and to the point. 0.4. What is the ratio of the Exports(as % of merchandise exports) of 1963 in Europe(all income levels) to that in Latin America(all income levels)?
Your answer should be very brief. 0.36. What is the ratio of the Exports(as % of merchandise exports) in 1964 in Europe(all income levels) to that in Latin America(all income levels)?
Provide a succinct answer. 0.32. What is the ratio of the Exports(as % of merchandise exports) of 1965 in Europe(all income levels) to that in Latin America(all income levels)?
Your answer should be very brief. 0.31. What is the ratio of the Exports(as % of merchandise exports) in 1962 in European Union to that in High income?
Offer a very short reply. 0.93. What is the ratio of the Exports(as % of merchandise exports) of 1963 in European Union to that in High income?
Provide a succinct answer. 0.88. What is the ratio of the Exports(as % of merchandise exports) of 1964 in European Union to that in High income?
Keep it short and to the point. 0.86. What is the ratio of the Exports(as % of merchandise exports) of 1965 in European Union to that in High income?
Provide a short and direct response. 0.88. What is the ratio of the Exports(as % of merchandise exports) of 1962 in European Union to that in High income: OECD?
Provide a short and direct response. 0.96. What is the ratio of the Exports(as % of merchandise exports) in 1963 in European Union to that in High income: OECD?
Ensure brevity in your answer.  0.94. What is the ratio of the Exports(as % of merchandise exports) of 1964 in European Union to that in High income: OECD?
Offer a terse response. 0.91. What is the ratio of the Exports(as % of merchandise exports) in 1965 in European Union to that in High income: OECD?
Keep it short and to the point. 0.93. What is the ratio of the Exports(as % of merchandise exports) of 1962 in European Union to that in Latin America(all income levels)?
Your answer should be compact. 0.39. What is the ratio of the Exports(as % of merchandise exports) of 1963 in European Union to that in Latin America(all income levels)?
Keep it short and to the point. 0.35. What is the ratio of the Exports(as % of merchandise exports) in 1964 in European Union to that in Latin America(all income levels)?
Offer a terse response. 0.3. What is the ratio of the Exports(as % of merchandise exports) of 1965 in European Union to that in Latin America(all income levels)?
Offer a terse response. 0.3. What is the ratio of the Exports(as % of merchandise exports) in 1962 in High income to that in High income: OECD?
Provide a succinct answer. 1.03. What is the ratio of the Exports(as % of merchandise exports) in 1963 in High income to that in High income: OECD?
Give a very brief answer. 1.06. What is the ratio of the Exports(as % of merchandise exports) of 1964 in High income to that in High income: OECD?
Offer a very short reply. 1.06. What is the ratio of the Exports(as % of merchandise exports) of 1965 in High income to that in High income: OECD?
Provide a short and direct response. 1.06. What is the ratio of the Exports(as % of merchandise exports) in 1962 in High income to that in Latin America(all income levels)?
Offer a very short reply. 0.41. What is the ratio of the Exports(as % of merchandise exports) of 1963 in High income to that in Latin America(all income levels)?
Ensure brevity in your answer.  0.4. What is the ratio of the Exports(as % of merchandise exports) of 1964 in High income to that in Latin America(all income levels)?
Your answer should be very brief. 0.35. What is the ratio of the Exports(as % of merchandise exports) of 1965 in High income to that in Latin America(all income levels)?
Provide a succinct answer. 0.34. What is the ratio of the Exports(as % of merchandise exports) of 1962 in High income: OECD to that in Latin America(all income levels)?
Your answer should be very brief. 0.4. What is the ratio of the Exports(as % of merchandise exports) in 1963 in High income: OECD to that in Latin America(all income levels)?
Make the answer very short. 0.37. What is the ratio of the Exports(as % of merchandise exports) of 1964 in High income: OECD to that in Latin America(all income levels)?
Make the answer very short. 0.33. What is the ratio of the Exports(as % of merchandise exports) of 1965 in High income: OECD to that in Latin America(all income levels)?
Ensure brevity in your answer.  0.32. What is the difference between the highest and the second highest Exports(as % of merchandise exports) of 1962?
Keep it short and to the point. 25.77. What is the difference between the highest and the second highest Exports(as % of merchandise exports) in 1963?
Keep it short and to the point. 25.88. What is the difference between the highest and the second highest Exports(as % of merchandise exports) in 1964?
Your answer should be compact. 30.86. What is the difference between the highest and the second highest Exports(as % of merchandise exports) of 1965?
Your response must be concise. 31.39. What is the difference between the highest and the lowest Exports(as % of merchandise exports) of 1962?
Your answer should be compact. 26.99. What is the difference between the highest and the lowest Exports(as % of merchandise exports) in 1963?
Offer a terse response. 27.87. What is the difference between the highest and the lowest Exports(as % of merchandise exports) of 1964?
Your answer should be compact. 33.27. What is the difference between the highest and the lowest Exports(as % of merchandise exports) in 1965?
Your answer should be compact. 33.32. 